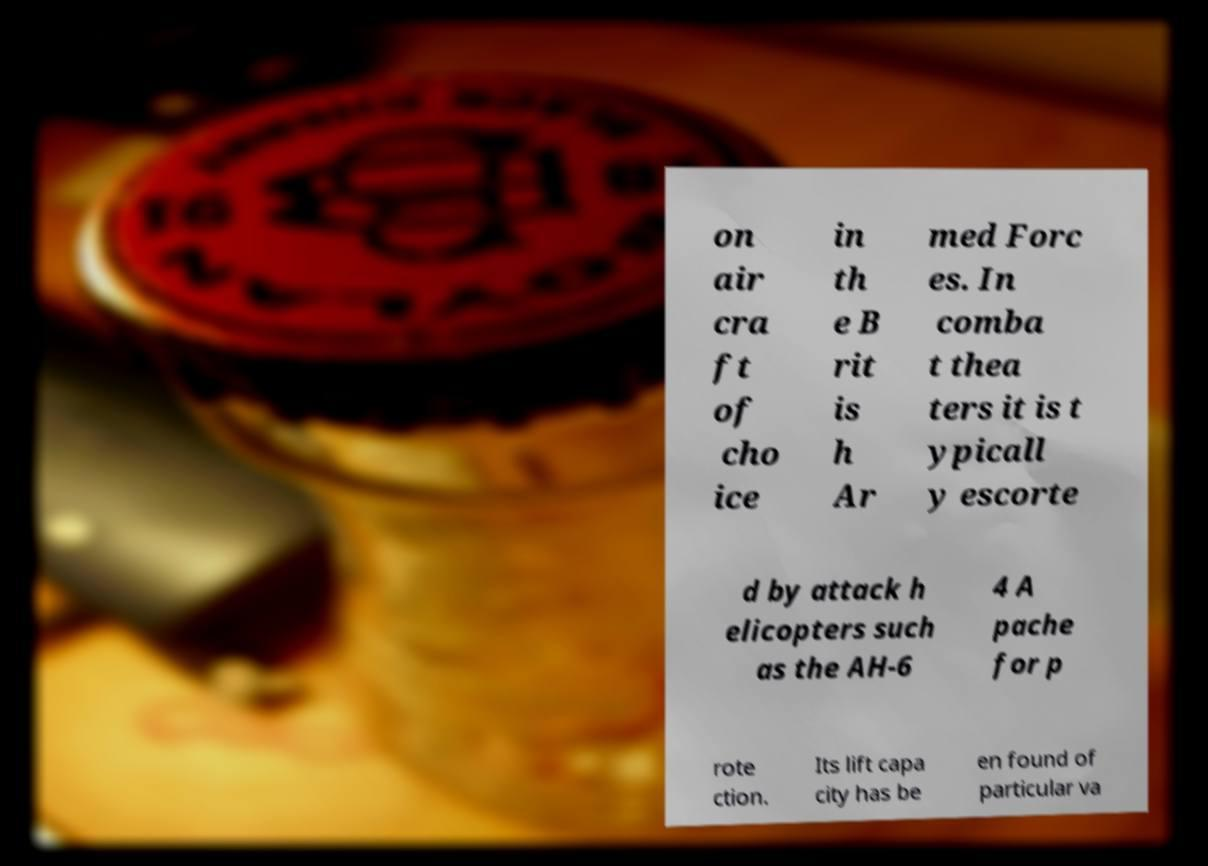I need the written content from this picture converted into text. Can you do that? on air cra ft of cho ice in th e B rit is h Ar med Forc es. In comba t thea ters it is t ypicall y escorte d by attack h elicopters such as the AH-6 4 A pache for p rote ction. Its lift capa city has be en found of particular va 